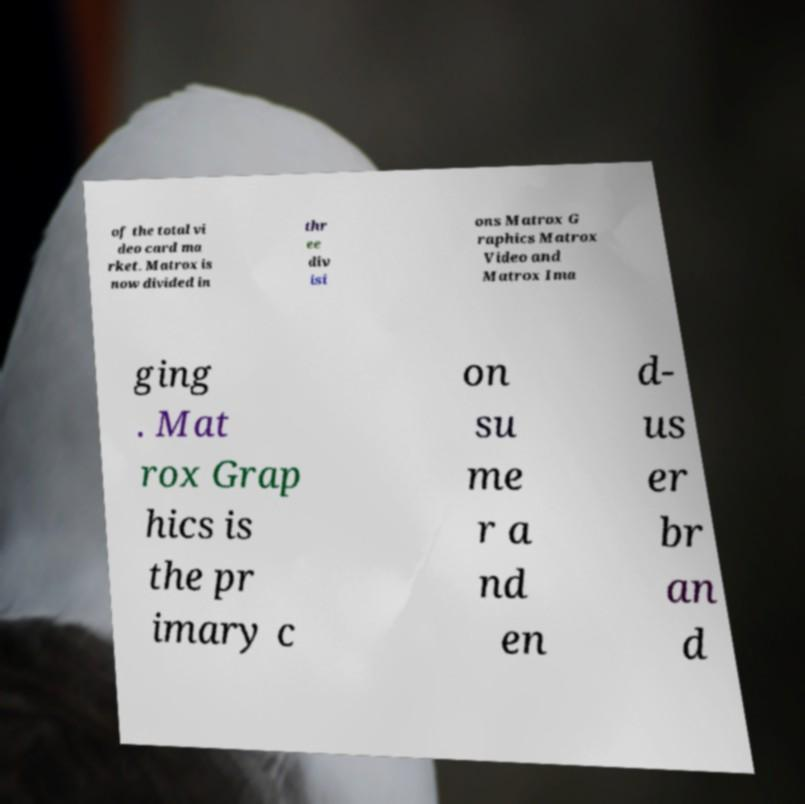Please read and relay the text visible in this image. What does it say? of the total vi deo card ma rket. Matrox is now divided in thr ee div isi ons Matrox G raphics Matrox Video and Matrox Ima ging . Mat rox Grap hics is the pr imary c on su me r a nd en d- us er br an d 